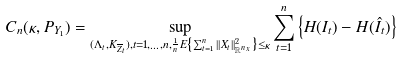<formula> <loc_0><loc_0><loc_500><loc_500>{ C } _ { n } ( \kappa , { P } _ { Y _ { 1 } } ) = \sup _ { ( \Lambda _ { t } , K _ { \overline { Z } _ { t } } ) , t = 1 , \dots , n , \frac { 1 } { n } { E } \left \{ \sum _ { t = 1 } ^ { n } | | X _ { t } | | _ { { \mathbb { R } } ^ { n _ { x } } } ^ { 2 } \right \} \leq \kappa } \sum _ { t = 1 } ^ { n } \left \{ H ( I _ { t } ) - H ( \hat { I } _ { t } ) \right \}</formula> 